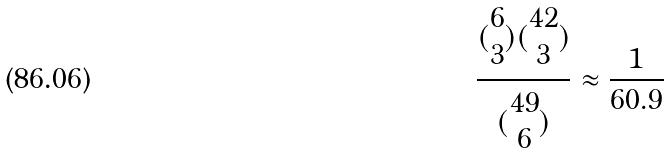Convert formula to latex. <formula><loc_0><loc_0><loc_500><loc_500>\frac { ( \begin{matrix} 6 \\ 3 \end{matrix} ) ( \begin{matrix} 4 2 \\ 3 \end{matrix} ) } { ( \begin{matrix} 4 9 \\ 6 \end{matrix} ) } \approx \frac { 1 } { 6 0 . 9 }</formula> 